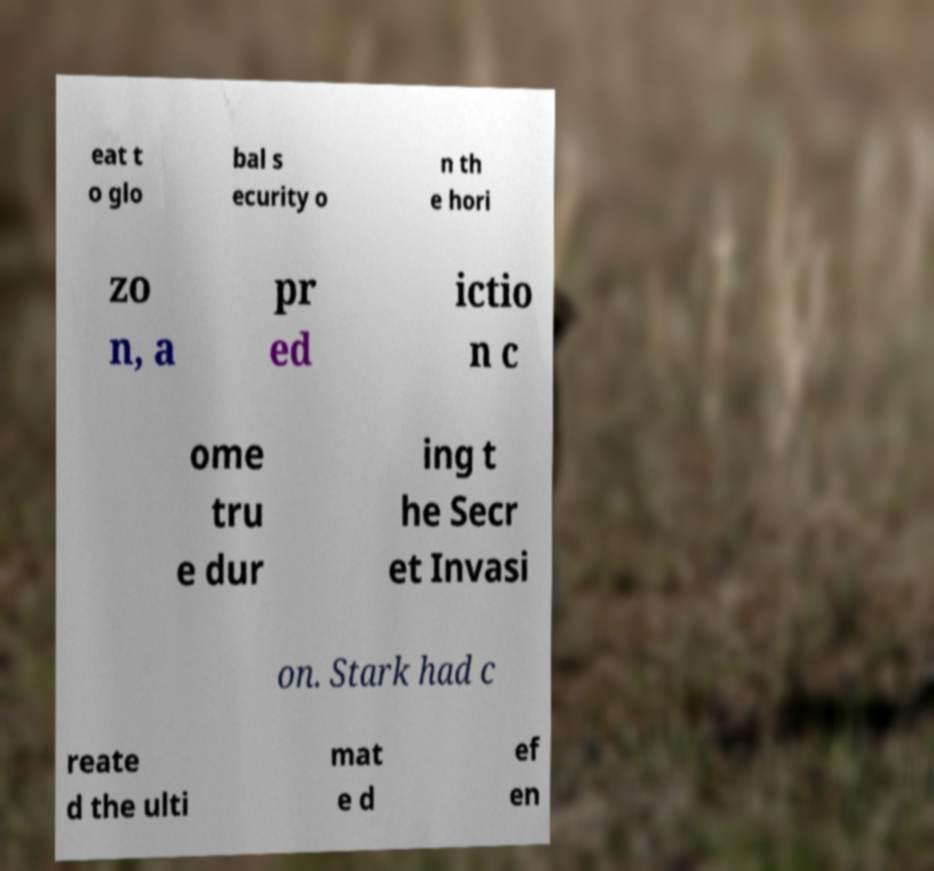Could you extract and type out the text from this image? eat t o glo bal s ecurity o n th e hori zo n, a pr ed ictio n c ome tru e dur ing t he Secr et Invasi on. Stark had c reate d the ulti mat e d ef en 